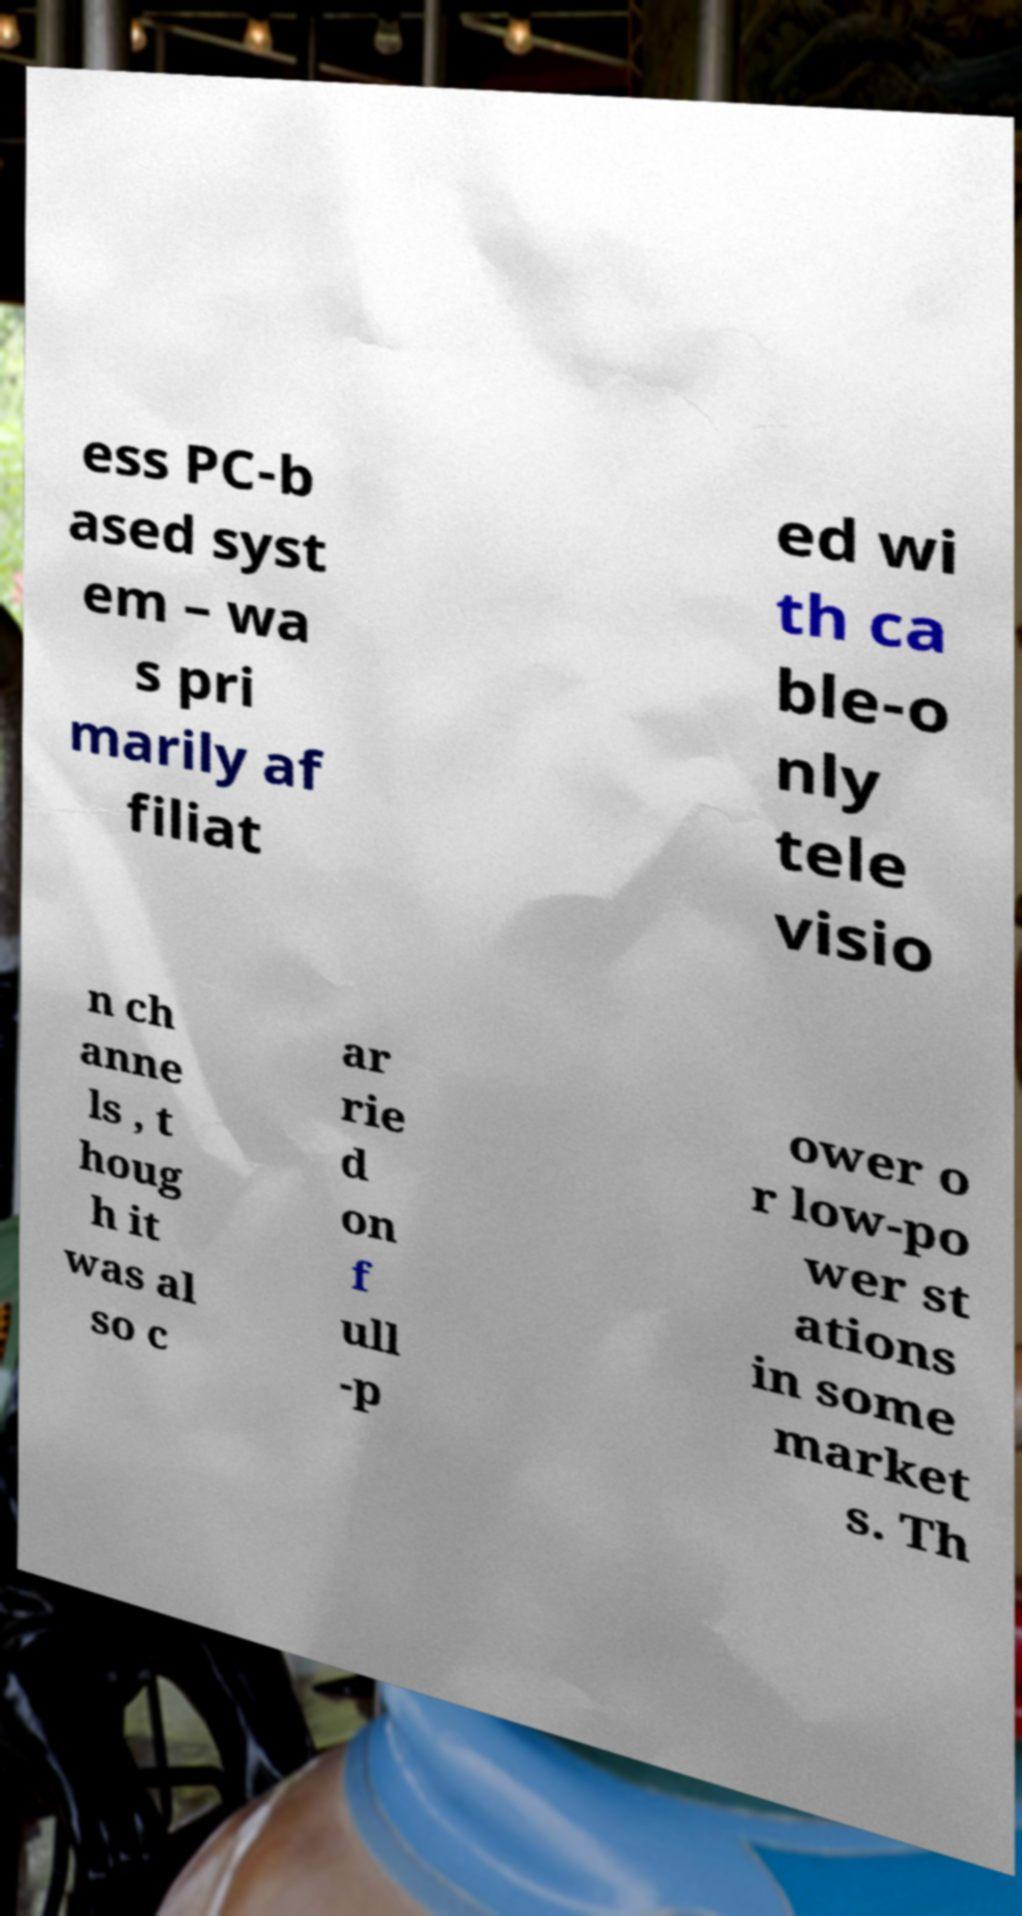Please identify and transcribe the text found in this image. ess PC-b ased syst em – wa s pri marily af filiat ed wi th ca ble-o nly tele visio n ch anne ls , t houg h it was al so c ar rie d on f ull -p ower o r low-po wer st ations in some market s. Th 